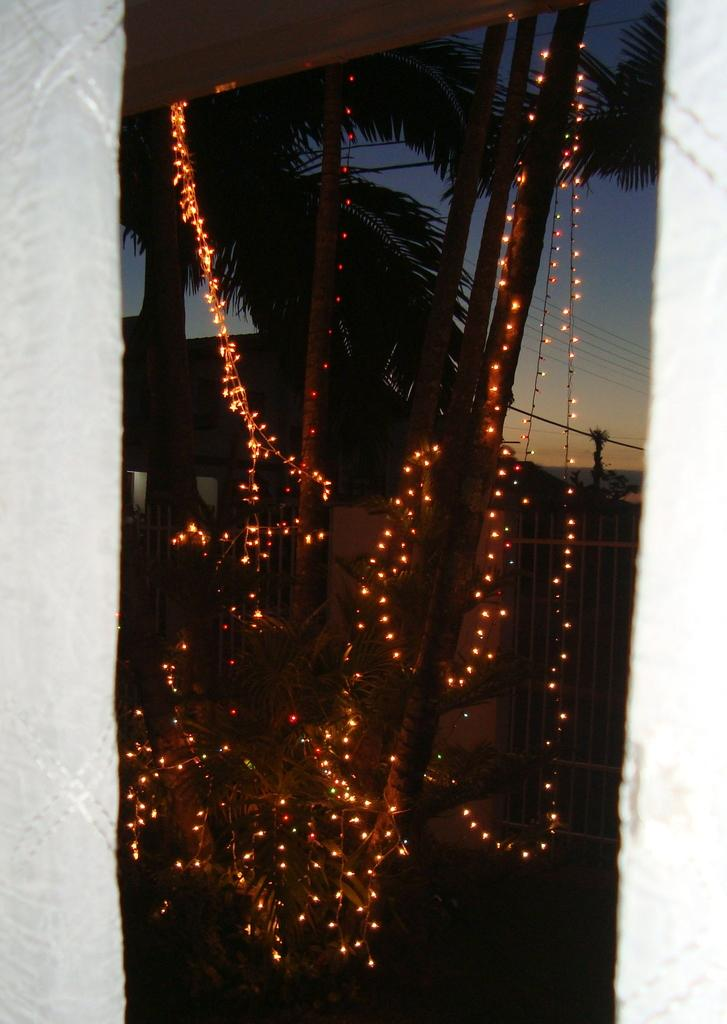What objects are tied to sticks in the image? There are lights tied to sticks in the image. What can be seen in the background of the image? There appears to be a pole, trees, a fence, and the sky visible in the background of the image. What is the purpose of the robin in the image? There is no robin present in the image, so it is not possible to determine its purpose. 